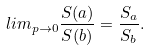Convert formula to latex. <formula><loc_0><loc_0><loc_500><loc_500>l i m _ { p \to 0 } \frac { S ( a ) } { S ( b ) } = \frac { S _ { a } } { S _ { b } } .</formula> 